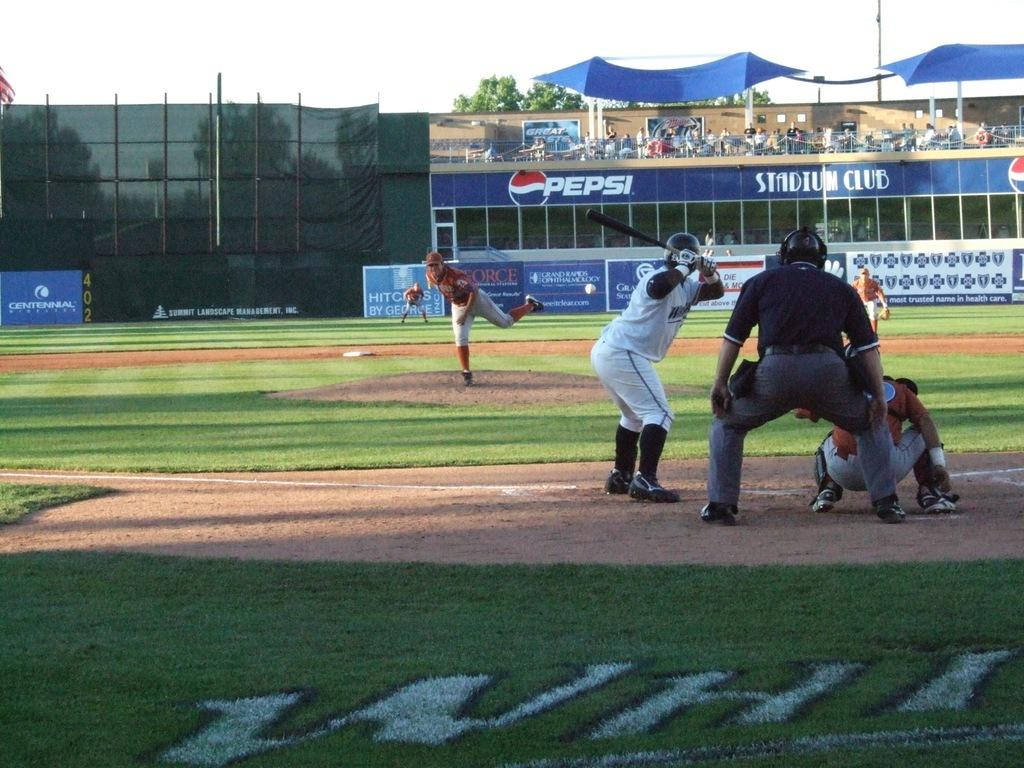<image>
Share a concise interpretation of the image provided. Pepsi and the logo are on a blue banner next to the stadium club. 